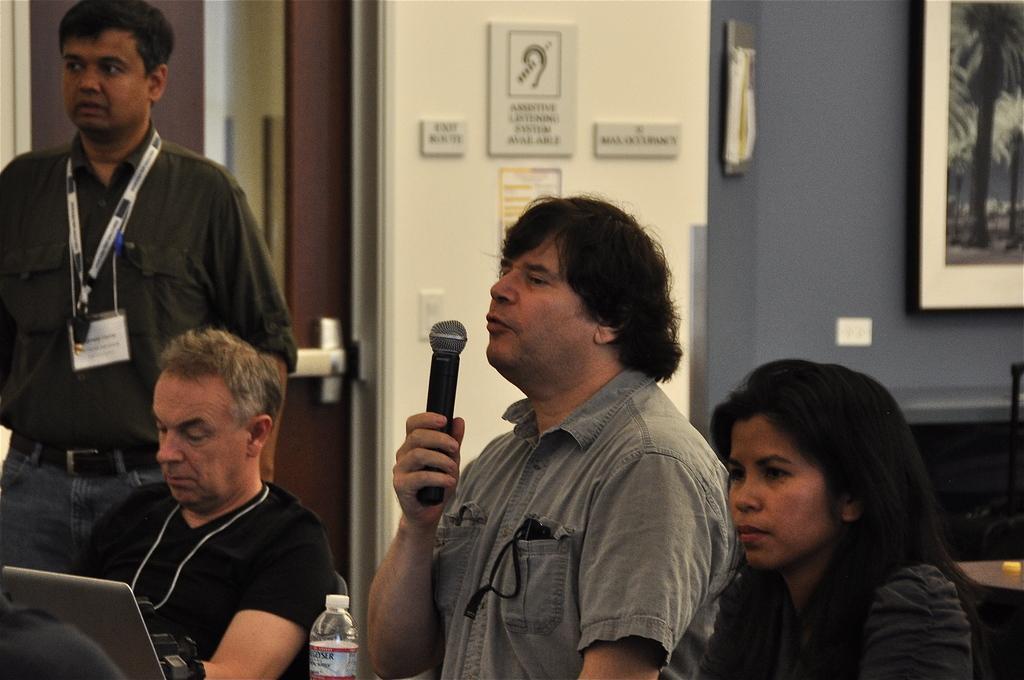Describe this image in one or two sentences. 3 people are sitting. the person at the center is holding a microphone and speaking. in front of them there is a bottle and a laptop. at the left there is a person standing. behind him there is a wall on which there is a photo frame in the right. 